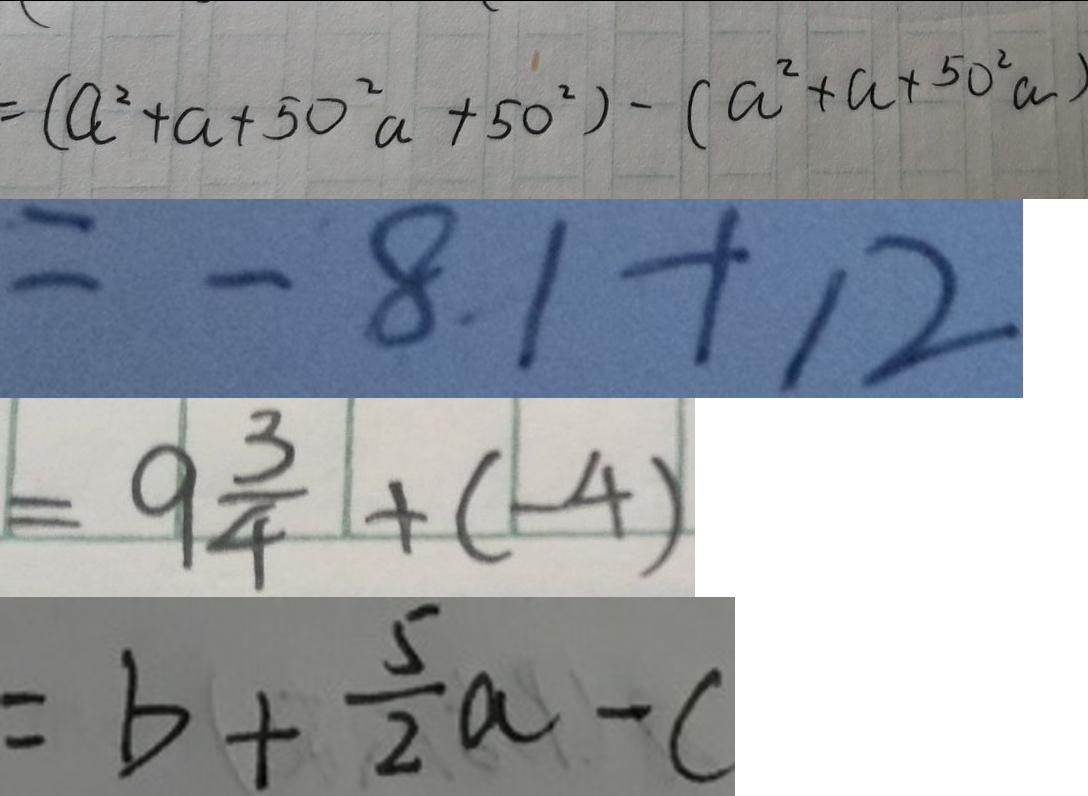<formula> <loc_0><loc_0><loc_500><loc_500>= ( a ^ { 2 } + a + 5 0 ^ { 2 } a + 5 0 ^ { 2 } ) - ( a ^ { 2 } + a + 5 0 ^ { 2 } a ) 
 = - 8 1 + 1 2 
 = 9 \frac { 3 } { 4 } + ( - 4 ) 
 = b + \frac { 5 } { 2 } a - c</formula> 